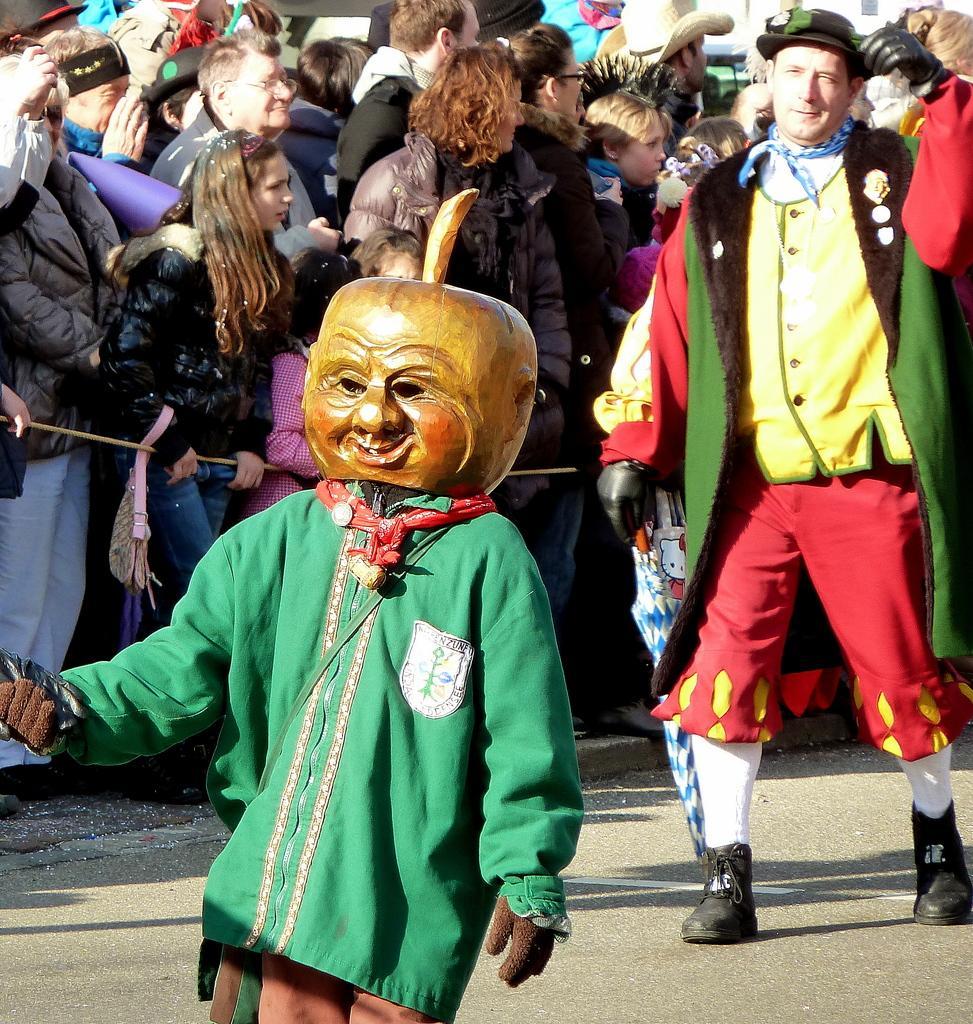How many people are in the group that is visible in the image? There is a group of people in the image. Can you describe the attire of any of the people in the group? Two people in the group are wearing costumes. What object can be seen in the image that might be used for tying or securing? There is a rope visible in the image. What type of rifle can be seen in the hands of one of the people in the image? There is no rifle present in the image. Can you hear any cries or sounds coming from the people in the image? The image is silent, and therefore no cries or sounds can be heard. 